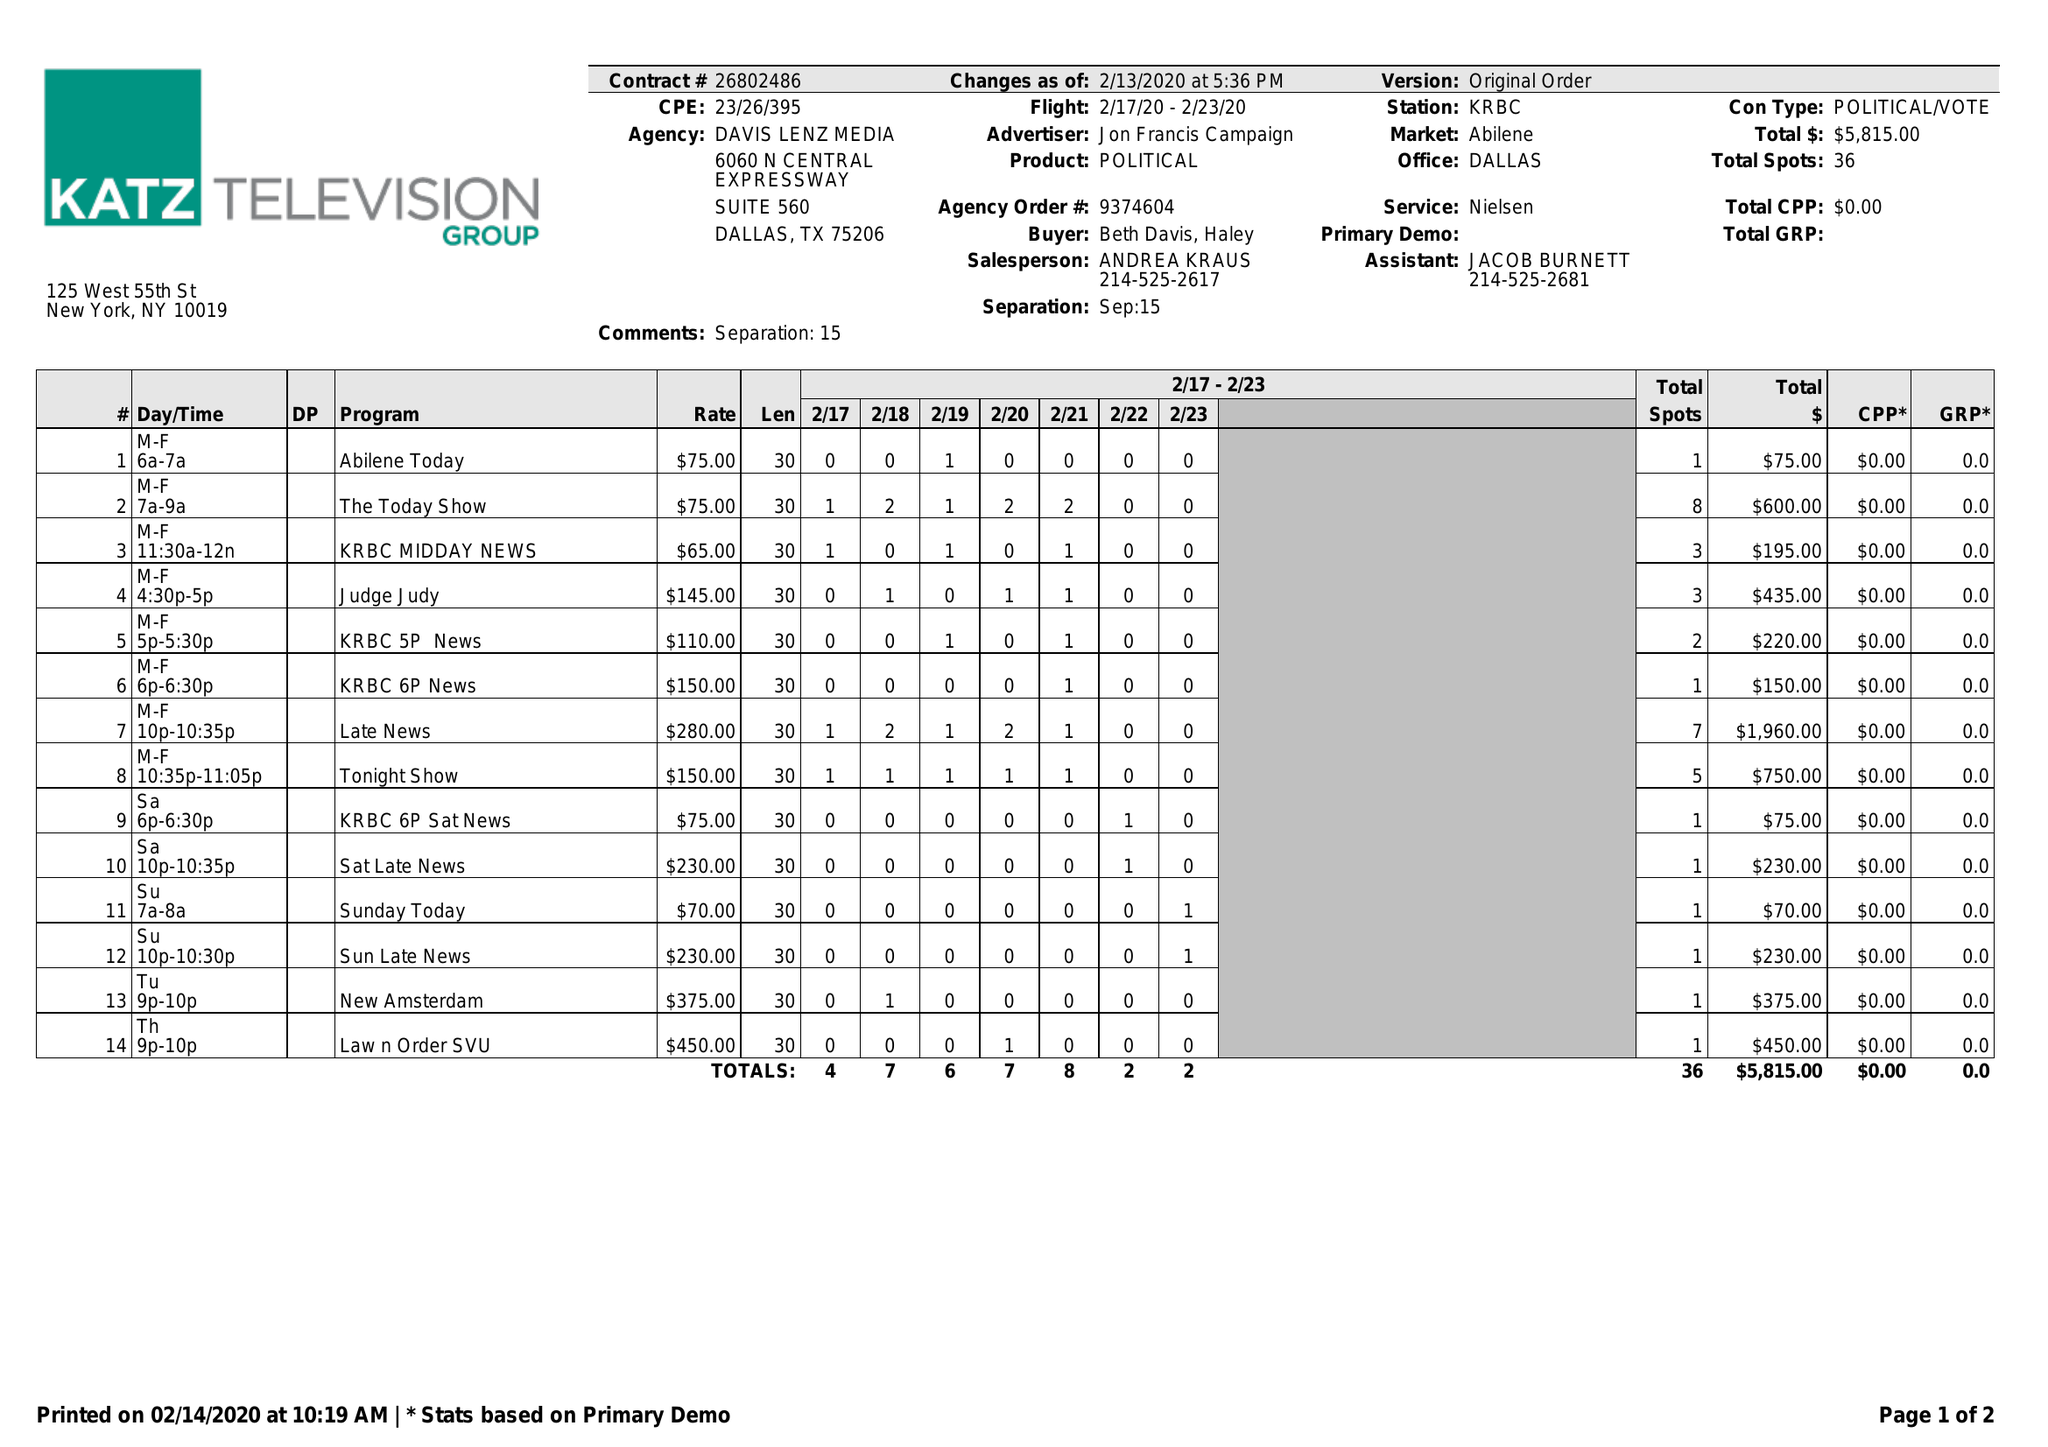What is the value for the advertiser?
Answer the question using a single word or phrase. JON FRANCIS CAMPAIGN 